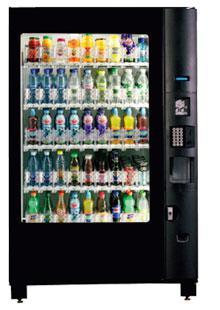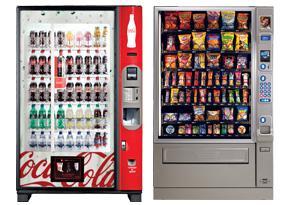The first image is the image on the left, the second image is the image on the right. Given the left and right images, does the statement "There are at least three vending machines in the image on the right." hold true? Answer yes or no. No. 